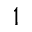<formula> <loc_0><loc_0><loc_500><loc_500>_ { 1 }</formula> 